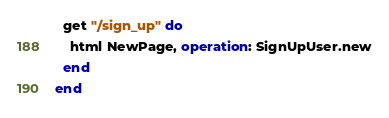Convert code to text. <code><loc_0><loc_0><loc_500><loc_500><_Crystal_>
  get "/sign_up" do
    html NewPage, operation: SignUpUser.new
  end
end
</code> 